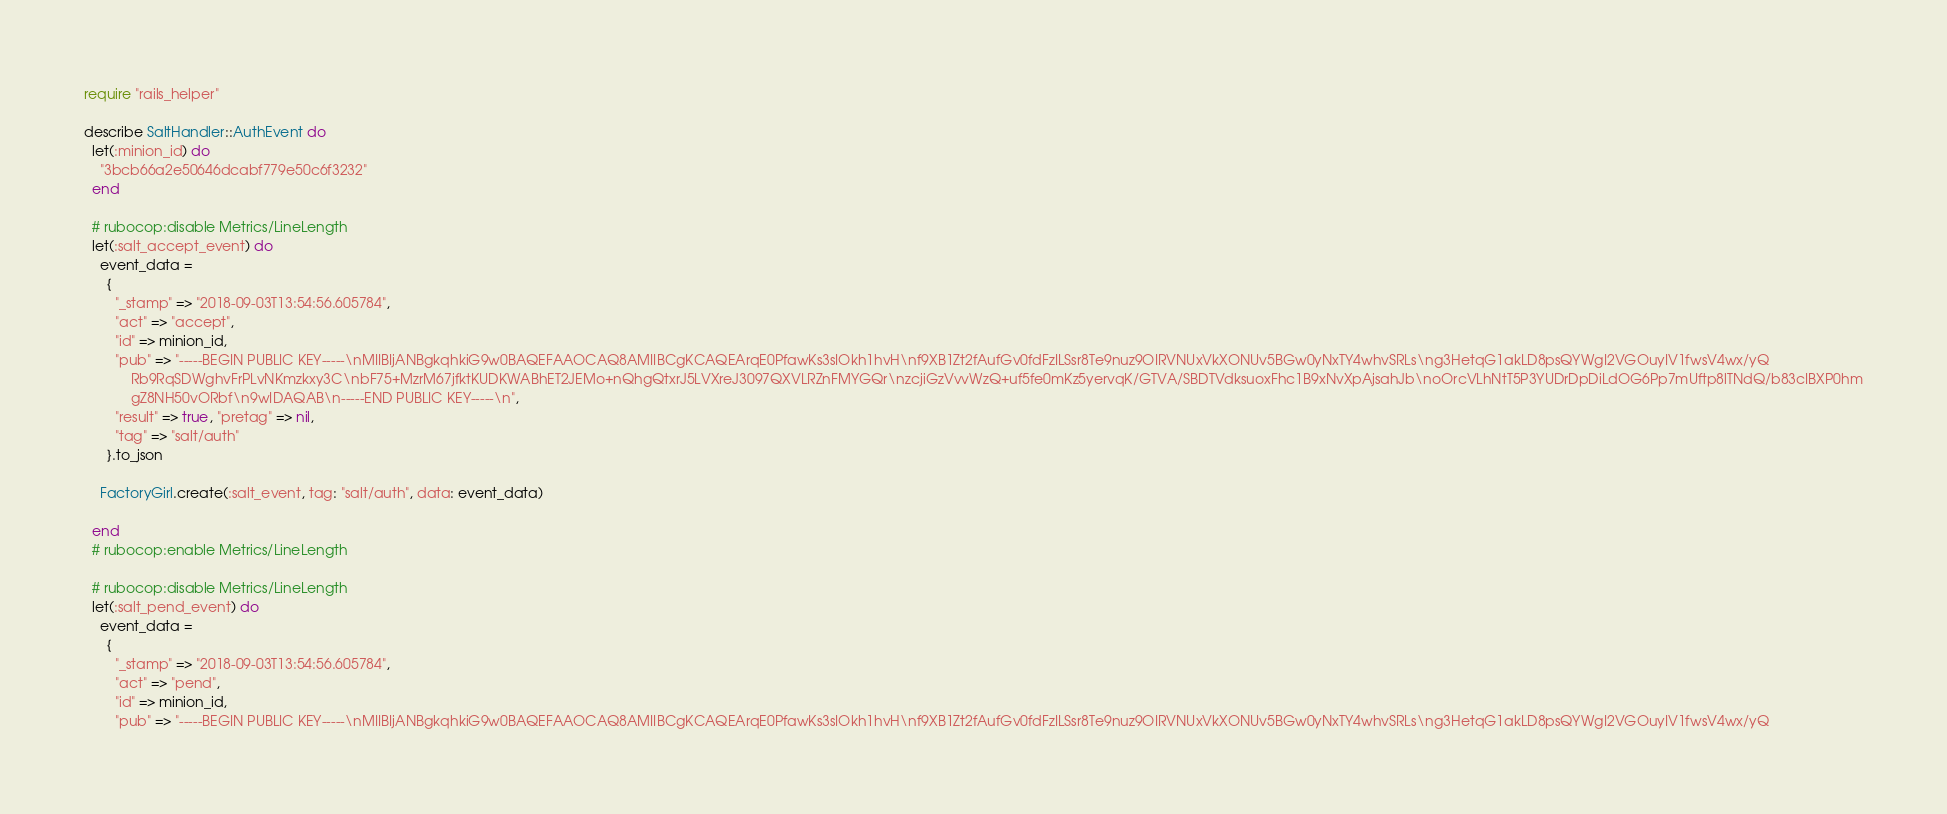Convert code to text. <code><loc_0><loc_0><loc_500><loc_500><_Ruby_>require "rails_helper"

describe SaltHandler::AuthEvent do
  let(:minion_id) do
    "3bcb66a2e50646dcabf779e50c6f3232"
  end

  # rubocop:disable Metrics/LineLength
  let(:salt_accept_event) do
    event_data =
      {
        "_stamp" => "2018-09-03T13:54:56.605784",
        "act" => "accept",
        "id" => minion_id,
        "pub" => "-----BEGIN PUBLIC KEY-----\nMIIBIjANBgkqhkiG9w0BAQEFAAOCAQ8AMIIBCgKCAQEArqE0PfawKs3sIOkh1hvH\nf9XB1Zt2fAufGv0fdFzILSsr8Te9nuz9OIRVNUxVkXONUv5BGw0yNxTY4whvSRLs\ng3HetqG1akLD8psQYWgI2VGOuyIV1fwsV4wx/yQ
            Rb9RqSDWghvFrPLvNKmzkxy3C\nbF75+MzrM67jfktKUDKWABhET2JEMo+nQhgQtxrJ5LVXreJ3097QXVLRZnFMYGQr\nzcjiGzVvvWzQ+uf5fe0mKz5yervqK/GTVA/SBDTVdksuoxFhc1B9xNvXpAjsahJb\noOrcVLhNtT5P3YUDrDpDiLdOG6Pp7mUftp8lTNdQ/b83cIBXP0hm
            gZ8NH50vORbf\n9wIDAQAB\n-----END PUBLIC KEY-----\n",
        "result" => true, "pretag" => nil,
        "tag" => "salt/auth"
      }.to_json

    FactoryGirl.create(:salt_event, tag: "salt/auth", data: event_data)

  end
  # rubocop:enable Metrics/LineLength

  # rubocop:disable Metrics/LineLength
  let(:salt_pend_event) do
    event_data =
      {
        "_stamp" => "2018-09-03T13:54:56.605784",
        "act" => "pend",
        "id" => minion_id,
        "pub" => "-----BEGIN PUBLIC KEY-----\nMIIBIjANBgkqhkiG9w0BAQEFAAOCAQ8AMIIBCgKCAQEArqE0PfawKs3sIOkh1hvH\nf9XB1Zt2fAufGv0fdFzILSsr8Te9nuz9OIRVNUxVkXONUv5BGw0yNxTY4whvSRLs\ng3HetqG1akLD8psQYWgI2VGOuyIV1fwsV4wx/yQ</code> 